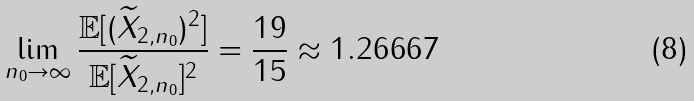Convert formula to latex. <formula><loc_0><loc_0><loc_500><loc_500>\lim _ { n _ { 0 } \to \infty } \frac { \mathbb { E } [ ( \widetilde { X } _ { 2 , n _ { 0 } } ) ^ { 2 } ] } { \mathbb { E } [ \widetilde { X } _ { 2 , n _ { 0 } } ] ^ { 2 } } = \frac { 1 9 } { 1 5 } \approx 1 . 2 6 6 6 7</formula> 